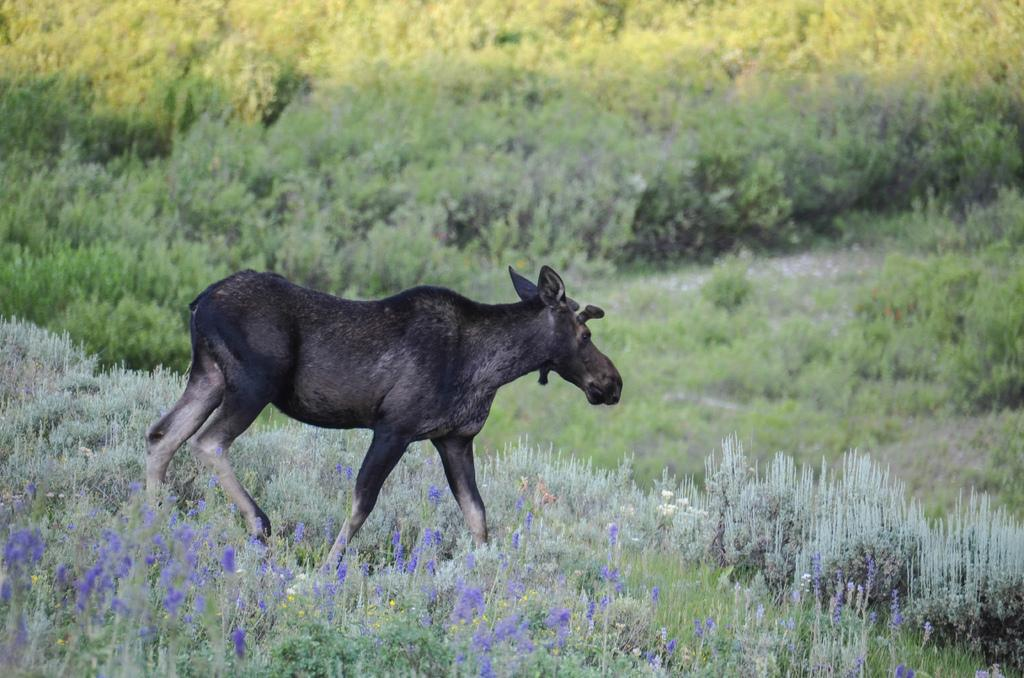What type of creature is present in the image? There is an animal in the image. Where is the animal located? The animal is in a field. What type of monkey is leading the group of animals in the image? There is no monkey present in the image, nor is there a group of animals. 